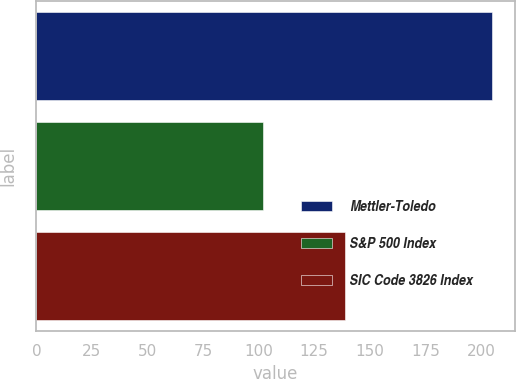Convert chart to OTSL. <chart><loc_0><loc_0><loc_500><loc_500><bar_chart><fcel>Mettler-Toledo<fcel>S&P 500 Index<fcel>SIC Code 3826 Index<nl><fcel>205<fcel>102<fcel>139<nl></chart> 